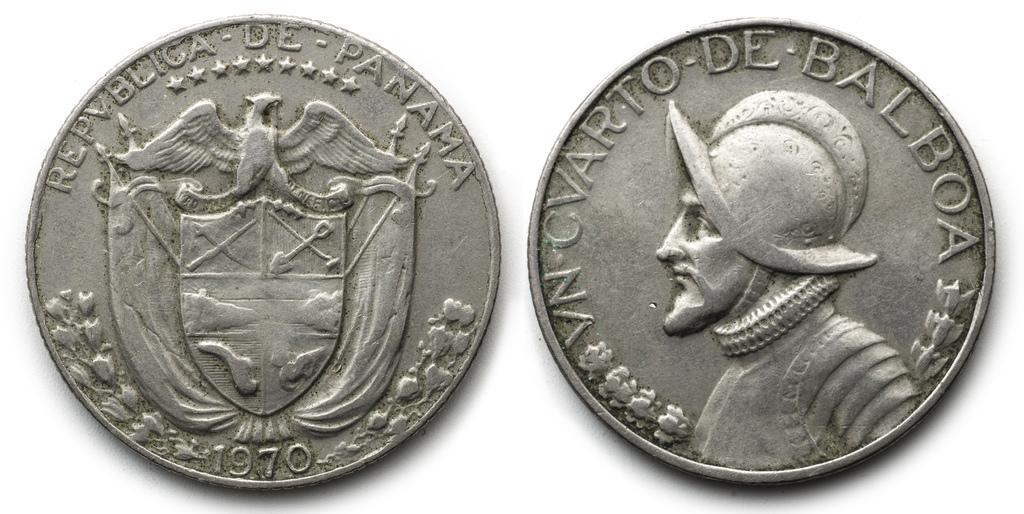<image>
Summarize the visual content of the image. The coin with a shield on it from Panama is dated 1970. 